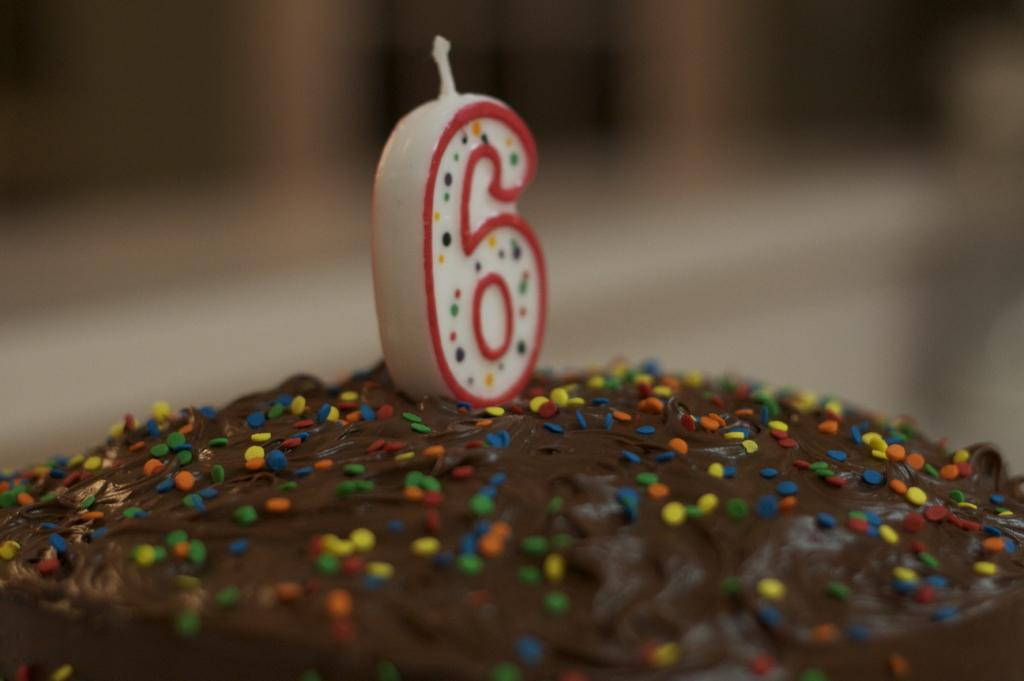What is the main subject of the image? The main subject of the image is a cake. What is on top of the cake? There is a number candle on the cake. What type of fold can be seen in the cake's icing? There is no fold visible in the cake's icing in the image. Is there a ship sailing near the cake in the image? There is no ship present in the image; it only features a cake with a number candle. Can you see a cave in the background of the image? There is no cave visible in the image; it only features a cake with a number candle. 